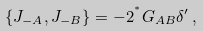Convert formula to latex. <formula><loc_0><loc_0><loc_500><loc_500>\{ J _ { - A } , J _ { - B } \} = - 2 ^ { ^ { * } } G _ { A B } \delta ^ { \prime } \, ,</formula> 